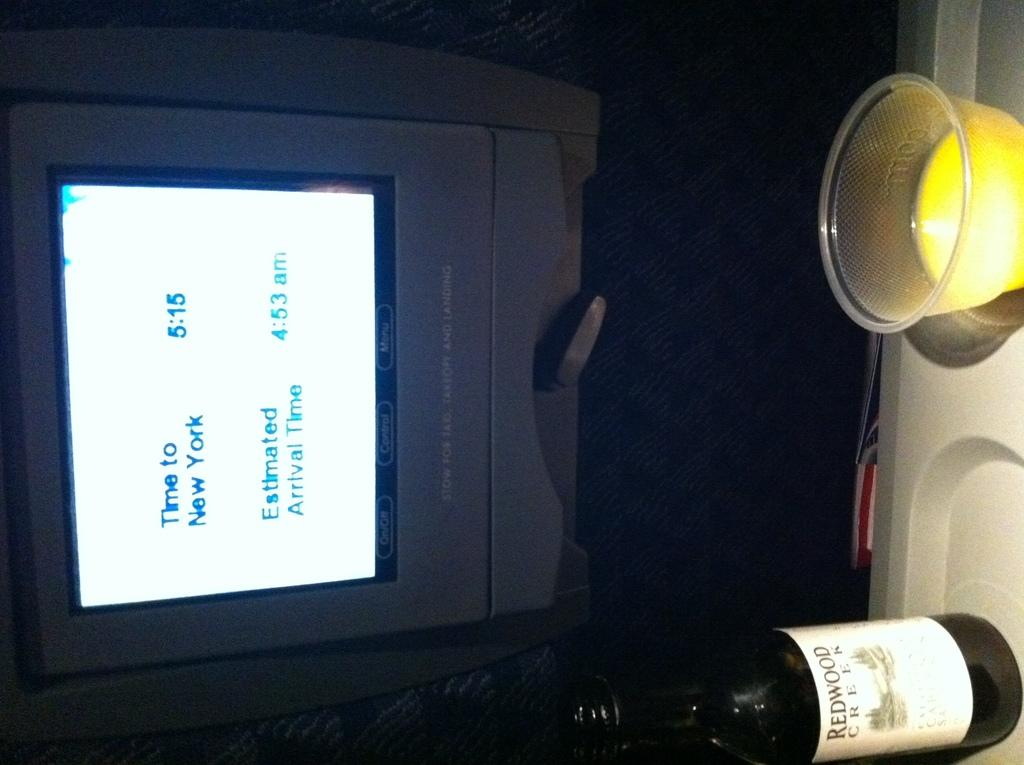<image>
Offer a succinct explanation of the picture presented. Screen with a bottle of alcohol that says "Redwood" on it. 